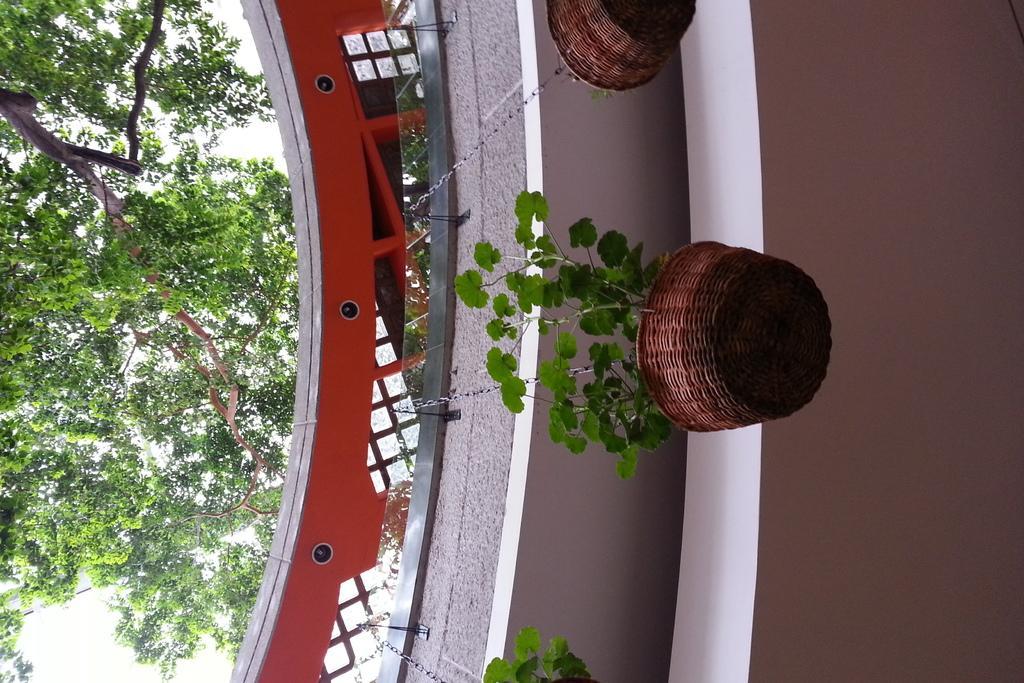How would you summarize this image in a sentence or two? In the image there are plants in basket hanging to wall, this seems to be building and on right side there is a tree, this is an inverted image 